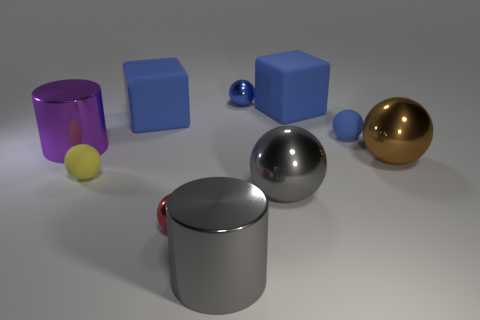Are these objects solid or hollow? Without additional context, it's difficult to determine if these objects are solid or hollow. However, they are likely to be modeled as solid for this type of rendering. 